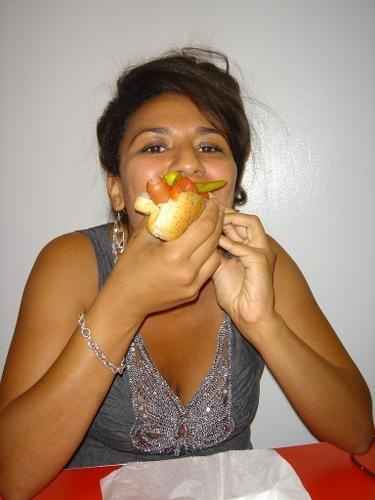How many bears are wearing blue?
Give a very brief answer. 0. 